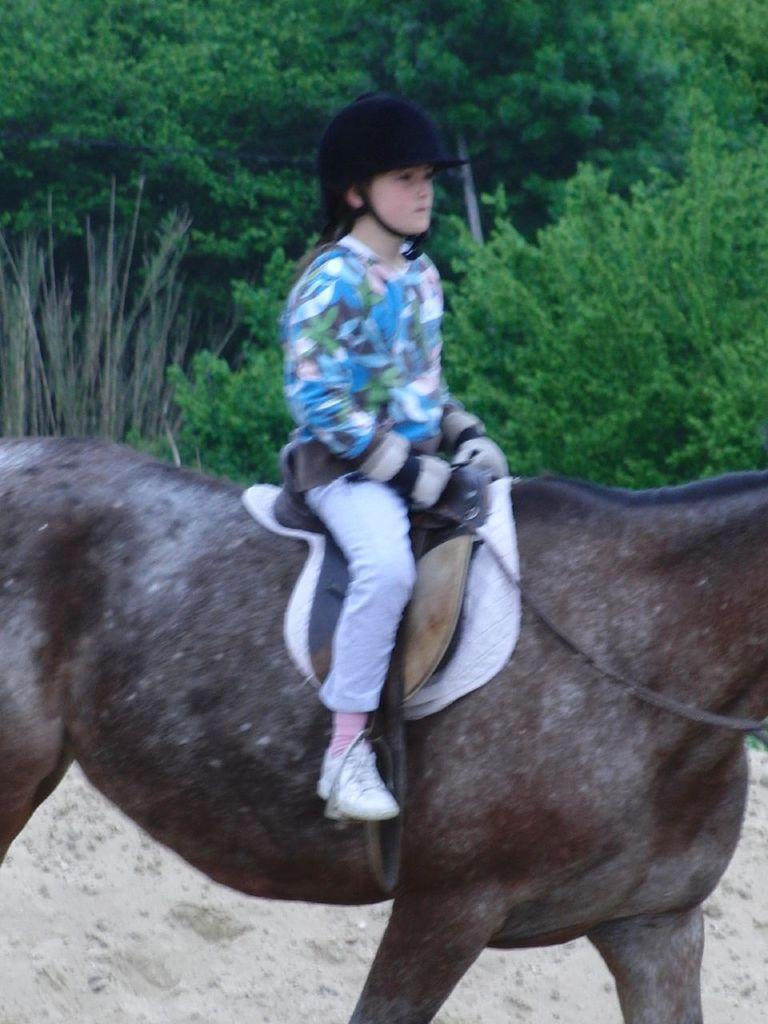Describe this image in one or two sentences. Here we can see a girl sitting on an animal. In the background there are trees. 